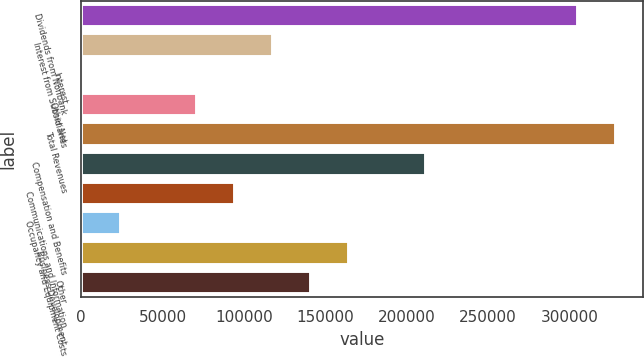Convert chart. <chart><loc_0><loc_0><loc_500><loc_500><bar_chart><fcel>Dividends from Nonbank<fcel>Interest from Subsidiaries<fcel>Interest<fcel>Other Net<fcel>Total Revenues<fcel>Compensation and Benefits<fcel>Communications and Information<fcel>Occupancy and Equipment Costs<fcel>Business Development<fcel>Other<nl><fcel>305353<fcel>117952<fcel>827<fcel>71102.3<fcel>328778<fcel>211653<fcel>94527.4<fcel>24252.1<fcel>164803<fcel>141378<nl></chart> 